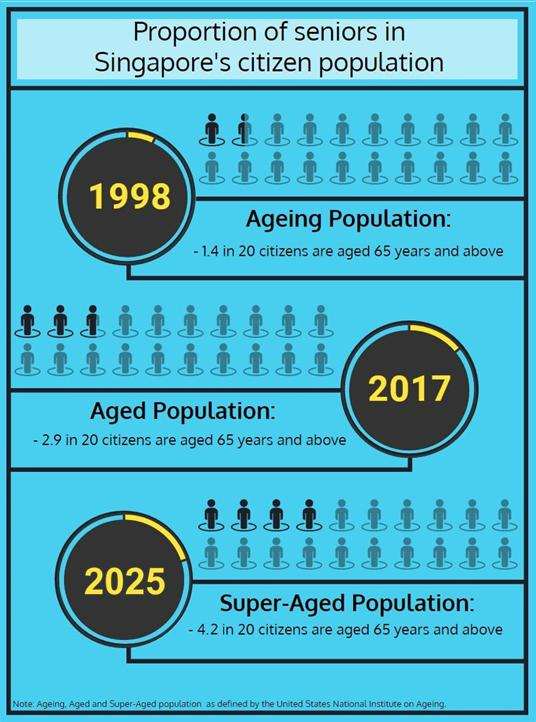Draw attention to some important aspects in this diagram. In 1998, the percentage of senior citizens in Singapore was 7%. In 2017, the percentage of senior citizens in Singapore was 14.5%. By 2025, it is projected that the percentage of senior citizens in Singapore will be approximately 21%. 